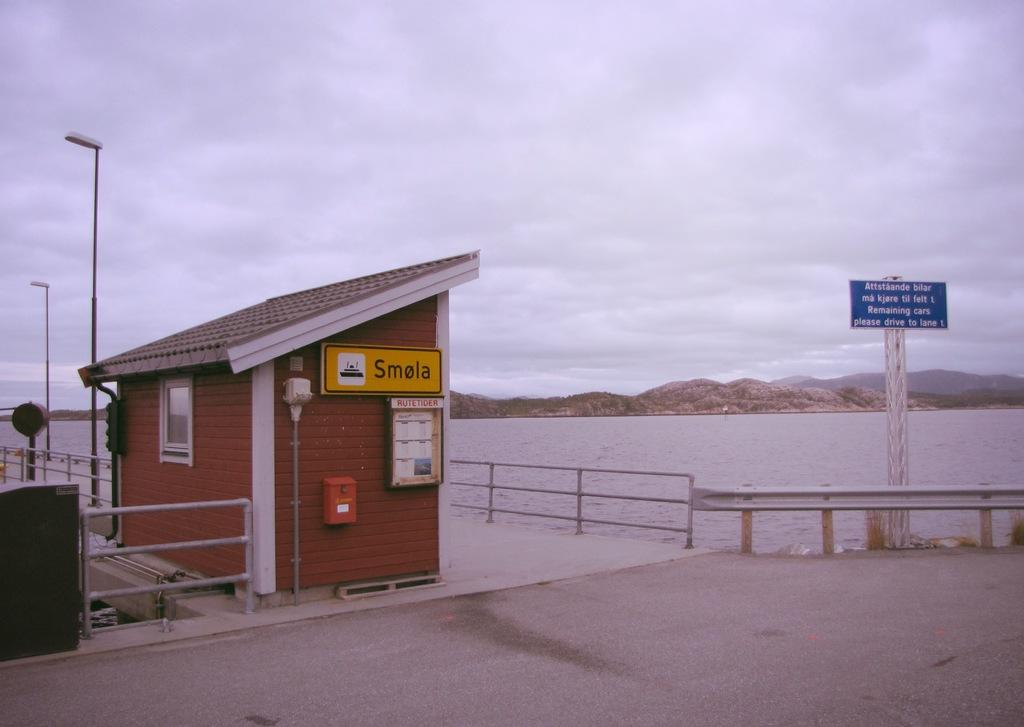What is the main setting of the picture? The main setting of the picture is a room in the foreground. What can be seen in the foreground of the picture besides the room? There is a railing, lights, a hoarding, and a dock in the foreground of the picture. What is visible in the center of the picture? There are hills and water in the center of the picture. How would you describe the sky in the picture? The sky is cloudy in the picture. How many cats can be seen playing with the family in the picture? There are no cats or family members present in the picture. 